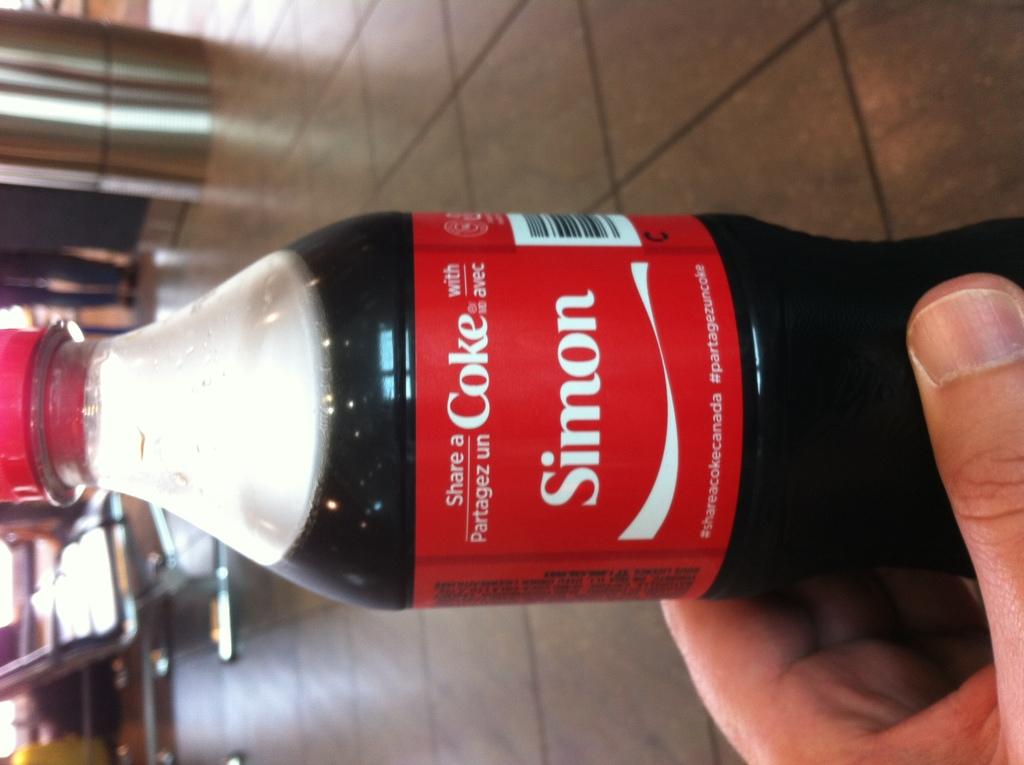Who should you share the coke with?
Provide a short and direct response. Simon. What hashtag is on the coke label?
Keep it short and to the point. #shareacokecanada. 